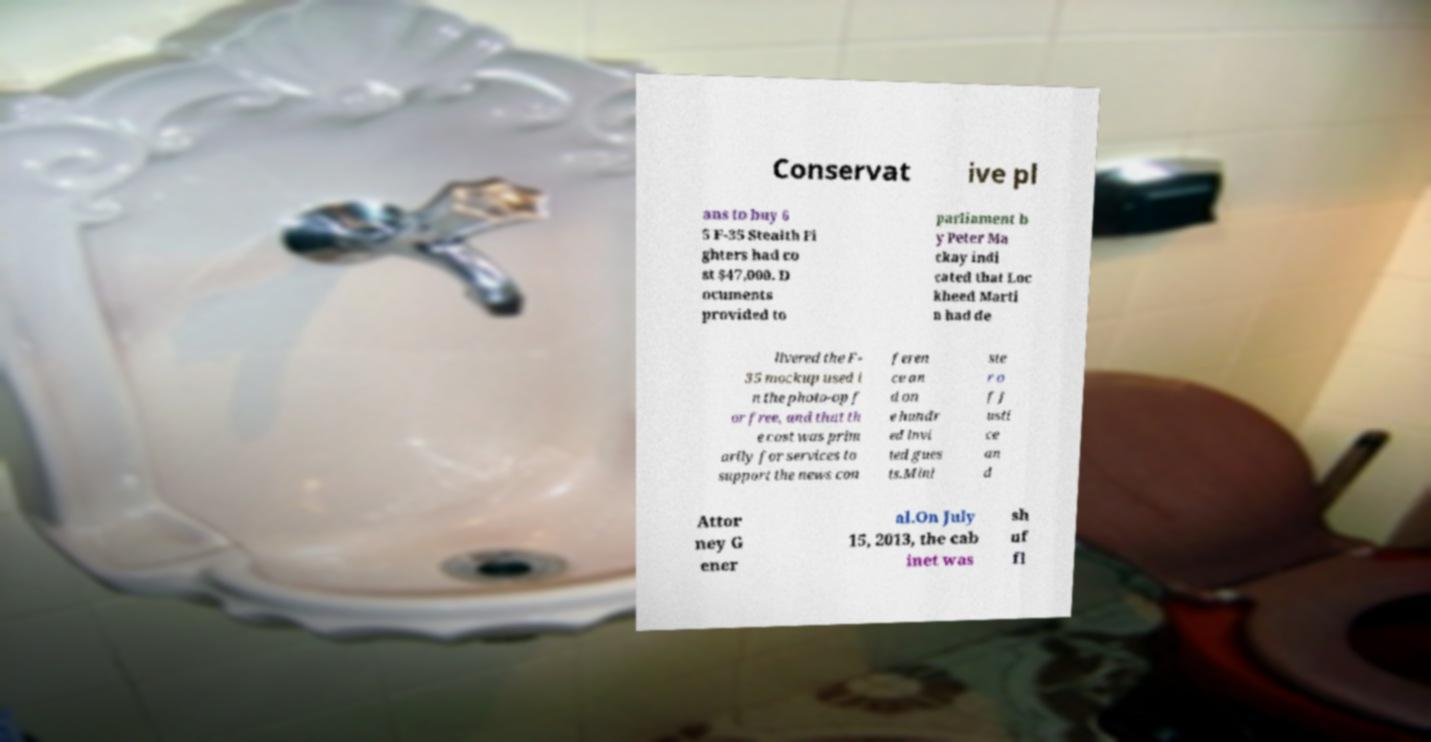I need the written content from this picture converted into text. Can you do that? Conservat ive pl ans to buy 6 5 F-35 Stealth Fi ghters had co st $47,000. D ocuments provided to parliament b y Peter Ma ckay indi cated that Loc kheed Marti n had de livered the F- 35 mockup used i n the photo-op f or free, and that th e cost was prim arily for services to support the news con feren ce an d on e hundr ed invi ted gues ts.Mini ste r o f J usti ce an d Attor ney G ener al.On July 15, 2013, the cab inet was sh uf fl 